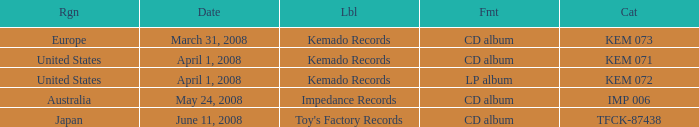Which Region has a Format of cd album, and a Label of kemado records, and a Catalog of kem 071? United States. Can you give me this table as a dict? {'header': ['Rgn', 'Date', 'Lbl', 'Fmt', 'Cat'], 'rows': [['Europe', 'March 31, 2008', 'Kemado Records', 'CD album', 'KEM 073'], ['United States', 'April 1, 2008', 'Kemado Records', 'CD album', 'KEM 071'], ['United States', 'April 1, 2008', 'Kemado Records', 'LP album', 'KEM 072'], ['Australia', 'May 24, 2008', 'Impedance Records', 'CD album', 'IMP 006'], ['Japan', 'June 11, 2008', "Toy's Factory Records", 'CD album', 'TFCK-87438']]} 